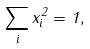Convert formula to latex. <formula><loc_0><loc_0><loc_500><loc_500>\sum _ { i } x _ { i } ^ { 2 } = 1 ,</formula> 